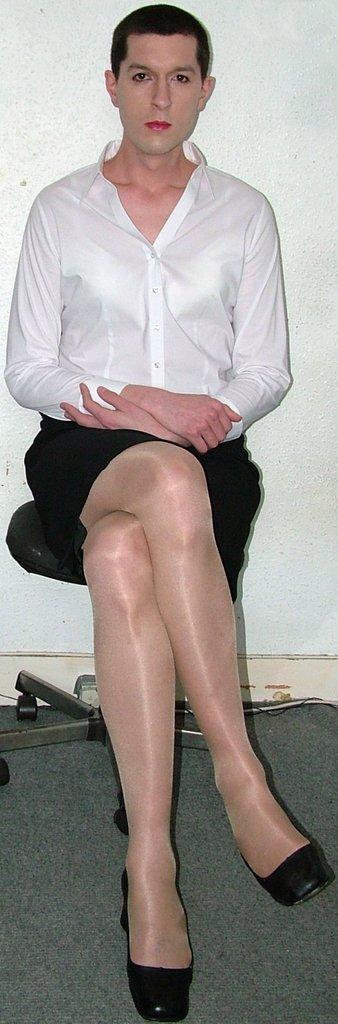In one or two sentences, can you explain what this image depicts? In this image we can see a person sitting on a chair. We can also see a wall. 